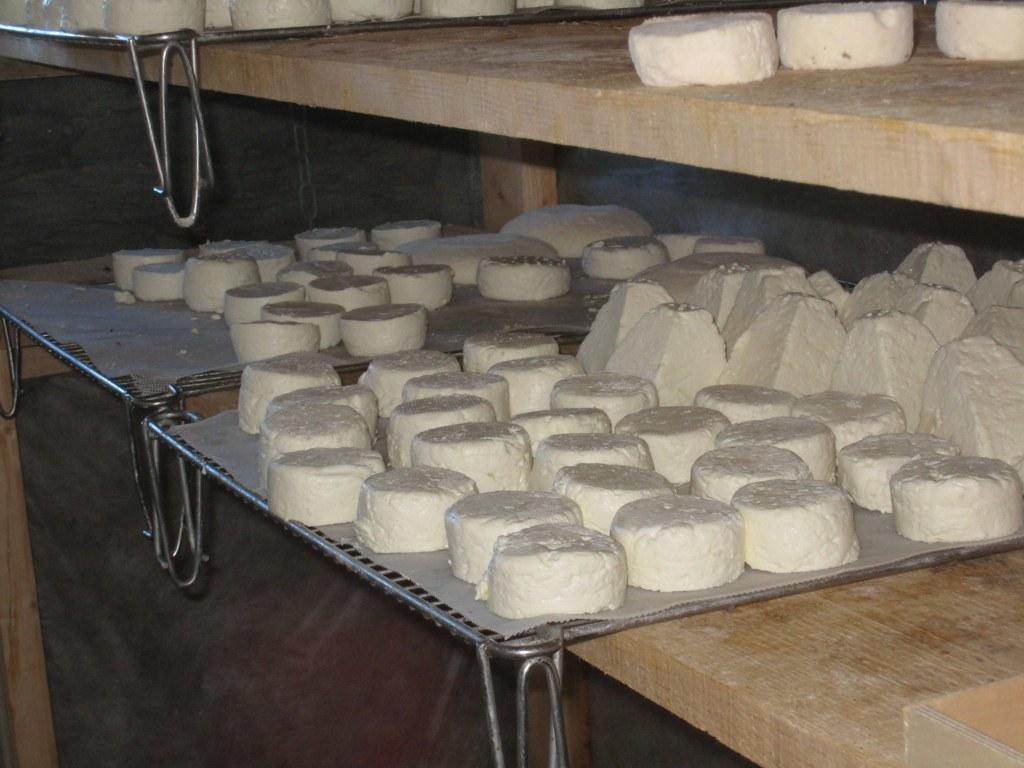Please provide a concise description of this image. In this image we can see food items on the metal plates on the wooden platforms. 